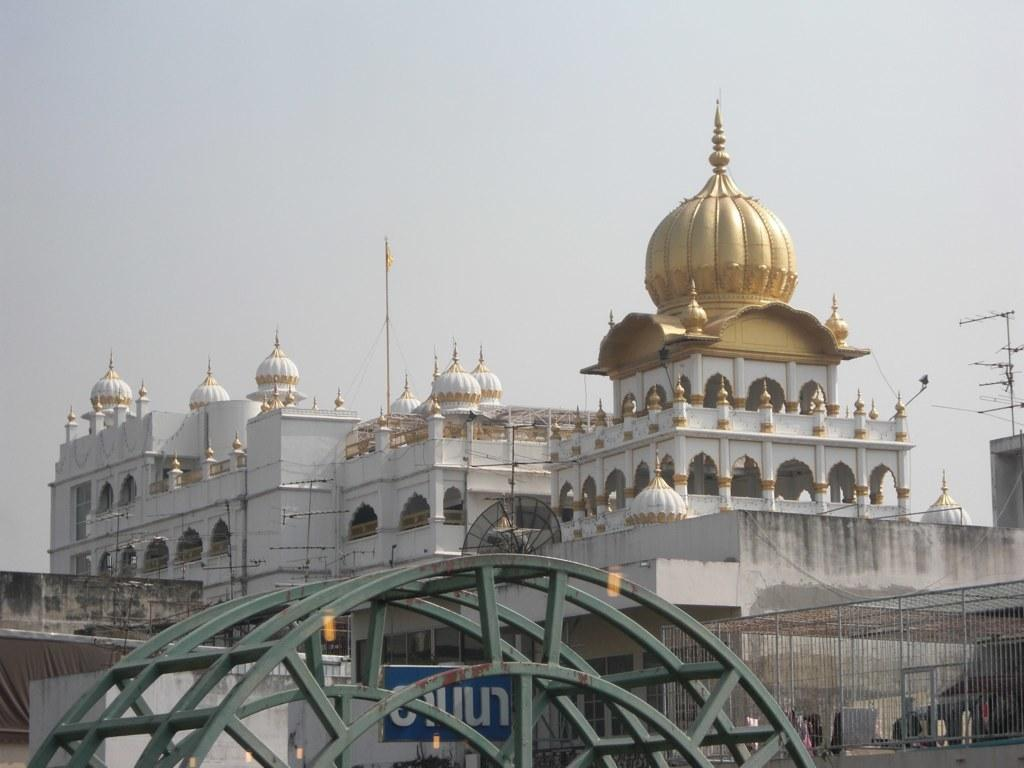What is the main feature of the image? There is a huge metal structure in the image. What else can be seen in the image besides the metal structure? There are buildings in the image. Are there any specific details about the metal structure? Metal railing is visible in the image. What is on top of the buildings? There are antennas on the buildings. What can be seen in the background of the image? The sky is visible in the background of the image. How many sacks of snow are visible on the metal structure in the image? There are no sacks of snow present in the image. 